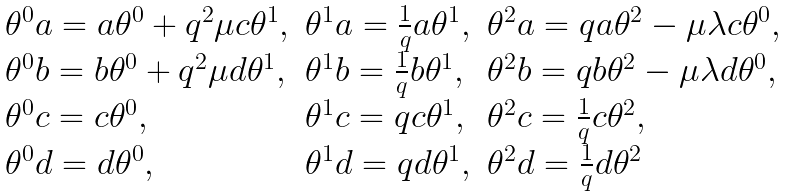Convert formula to latex. <formula><loc_0><loc_0><loc_500><loc_500>\begin{array} { l l l } \theta ^ { 0 } a = a \theta ^ { 0 } + q ^ { 2 } \mu c \theta ^ { 1 } , & \theta ^ { 1 } a = \frac { 1 } { q } a \theta ^ { 1 } , & \theta ^ { 2 } a = q a \theta ^ { 2 } - \mu \lambda c \theta ^ { 0 } , \\ \theta ^ { 0 } b = b \theta ^ { 0 } + q ^ { 2 } \mu d \theta ^ { 1 } , & \theta ^ { 1 } b = \frac { 1 } { q } b \theta ^ { 1 } , & \theta ^ { 2 } b = q b \theta ^ { 2 } - \mu \lambda d \theta ^ { 0 } , \\ \theta ^ { 0 } c = c \theta ^ { 0 } , & \theta ^ { 1 } c = q c \theta ^ { 1 } , & \theta ^ { 2 } c = \frac { 1 } { q } c \theta ^ { 2 } , \\ \theta ^ { 0 } d = d \theta ^ { 0 } , & \theta ^ { 1 } d = q d \theta ^ { 1 } , & \theta ^ { 2 } d = \frac { 1 } { q } d \theta ^ { 2 } \end{array}</formula> 